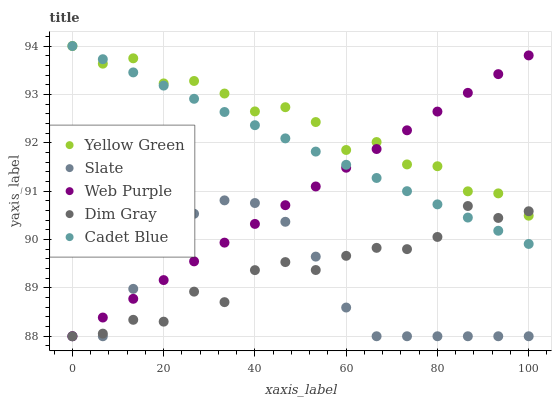Does Slate have the minimum area under the curve?
Answer yes or no. Yes. Does Yellow Green have the maximum area under the curve?
Answer yes or no. Yes. Does Web Purple have the minimum area under the curve?
Answer yes or no. No. Does Web Purple have the maximum area under the curve?
Answer yes or no. No. Is Cadet Blue the smoothest?
Answer yes or no. Yes. Is Dim Gray the roughest?
Answer yes or no. Yes. Is Web Purple the smoothest?
Answer yes or no. No. Is Web Purple the roughest?
Answer yes or no. No. Does Web Purple have the lowest value?
Answer yes or no. Yes. Does Yellow Green have the lowest value?
Answer yes or no. No. Does Yellow Green have the highest value?
Answer yes or no. Yes. Does Web Purple have the highest value?
Answer yes or no. No. Is Slate less than Yellow Green?
Answer yes or no. Yes. Is Yellow Green greater than Slate?
Answer yes or no. Yes. Does Cadet Blue intersect Web Purple?
Answer yes or no. Yes. Is Cadet Blue less than Web Purple?
Answer yes or no. No. Is Cadet Blue greater than Web Purple?
Answer yes or no. No. Does Slate intersect Yellow Green?
Answer yes or no. No. 